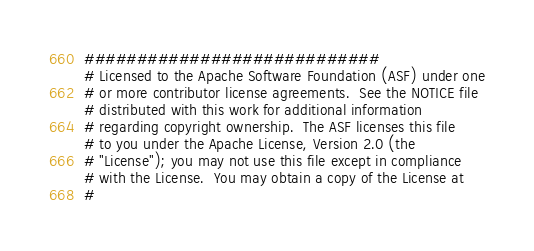Convert code to text. <code><loc_0><loc_0><loc_500><loc_500><_Python_>############################
# Licensed to the Apache Software Foundation (ASF) under one
# or more contributor license agreements.  See the NOTICE file
# distributed with this work for additional information
# regarding copyright ownership.  The ASF licenses this file
# to you under the Apache License, Version 2.0 (the
# "License"); you may not use this file except in compliance
# with the License.  You may obtain a copy of the License at
#</code> 